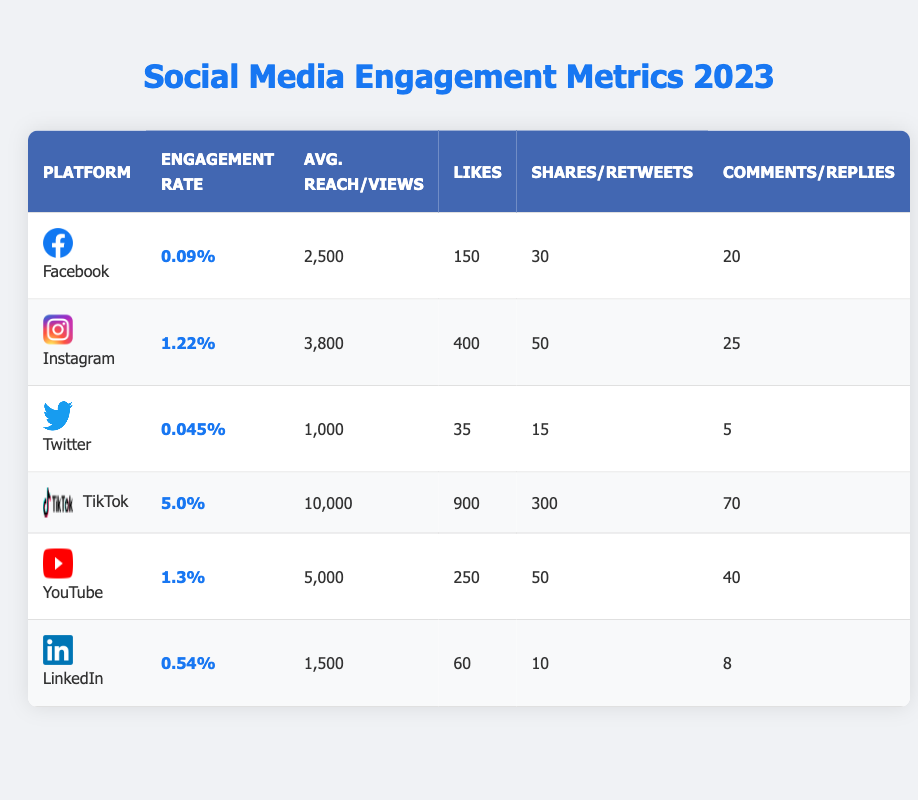What is the engagement rate for TikTok? The engagement rate for TikTok is stated directly in the table under the "Engagement Rate" column.
Answer: 5.0% Which platform has the highest average post reach? By comparing the values in the "Avg. Reach/Views" column, TikTok has the highest reach at 10,000 views.
Answer: TikTok How many likes does an average Instagram post receive? The number of likes for an average Instagram post is found in the "Likes" column, where it shows 400 likes.
Answer: 400 What is the average engagement rate across all platforms? To find the average engagement rate, we sum the engagement rates (0.09% + 1.22% + 0.045% + 5.0% + 1.3% + 0.54%) and divide by 6, resulting in an average engagement rate of approximately 1.0242%.
Answer: 1.0242% Is the average post reach for LinkedIn higher than that for Twitter? The average post reach for LinkedIn is 1,500 while for Twitter it is 1,000, confirming that LinkedIn has a higher average reach than Twitter.
Answer: Yes How do the shares per post on Facebook compare to those on YouTube? Facebook has 30 shares per post, while YouTube has 50 shares per post. Since 50 is greater than 30, YouTube has more shares per post than Facebook.
Answer: YouTube has more shares per post What is the total number of likes across all platforms? The total number of likes is calculated by summing the values (150 + 400 + 35 + 900 + 250 + 60), which equals 1,795.
Answer: 1,795 Does TikTok outperform other platforms in terms of comments per post/video? TikTok's comments per video are 70, which is higher than any other platform listed, making it the leader in comments.
Answer: Yes Which platform has the lowest average engagement rate? The lowest engagement rate is found by reviewing the "Engagement Rate" column, where Twitter shows 0.045%, the smallest value.
Answer: Twitter If you combine the average engagement rates of Facebook and Instagram, what do you get? Combining the numbers (0.09% + 1.22%) results in 1.31%.
Answer: 1.31% 